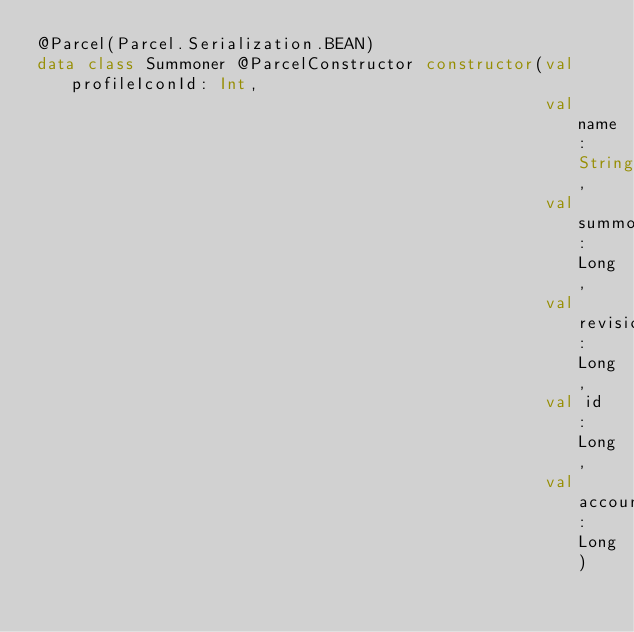Convert code to text. <code><loc_0><loc_0><loc_500><loc_500><_Kotlin_>@Parcel(Parcel.Serialization.BEAN)
data class Summoner @ParcelConstructor constructor(val profileIconId: Int,
                                                   val name: String,
                                                   val summonerLevel: Long,
                                                   val revisionDate: Long,
                                                   val id: Long,
                                                   val accountId: Long)
</code> 